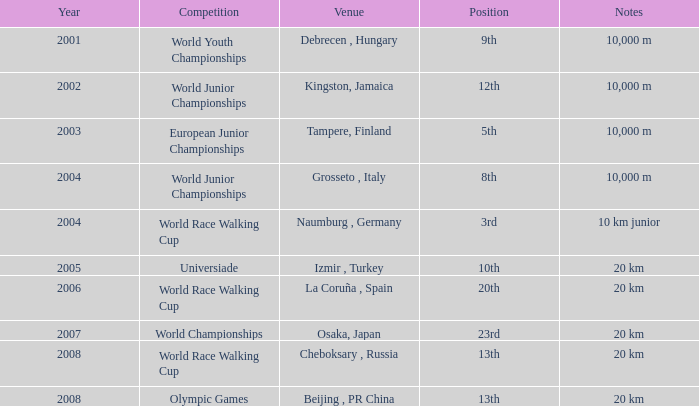In what year did he participate in the universiade? 2005.0. 